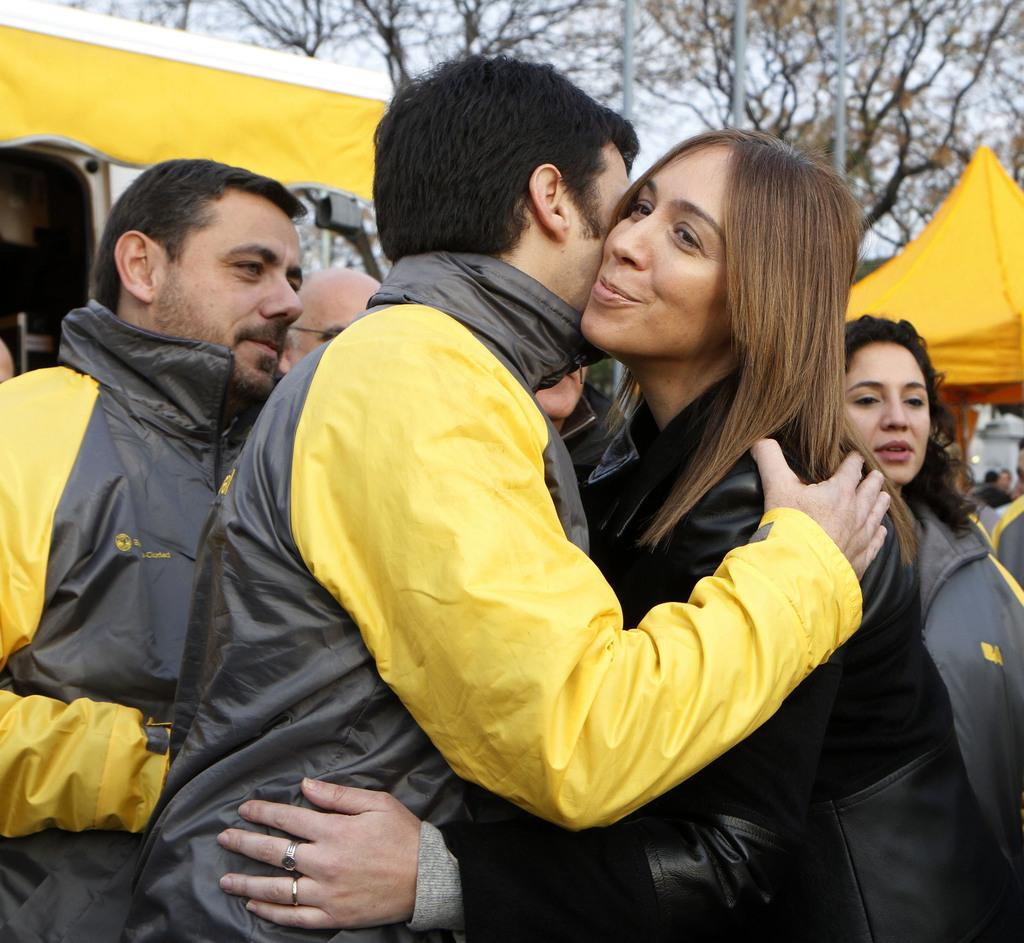What can be seen in the image involving people? There are people standing in the image. What are the people wearing? The people are wearing clothes. Can you describe any specific detail about one of the people? A woman on the right side is wearing finger rings. What type of structures are present in the image? There are tents in the image. What natural elements can be seen in the image? There are trees and poles in the image. Is there a girl sailing a stream in the image? There is no girl sailing a stream in the image; it does not depict any water or sailing activity. 